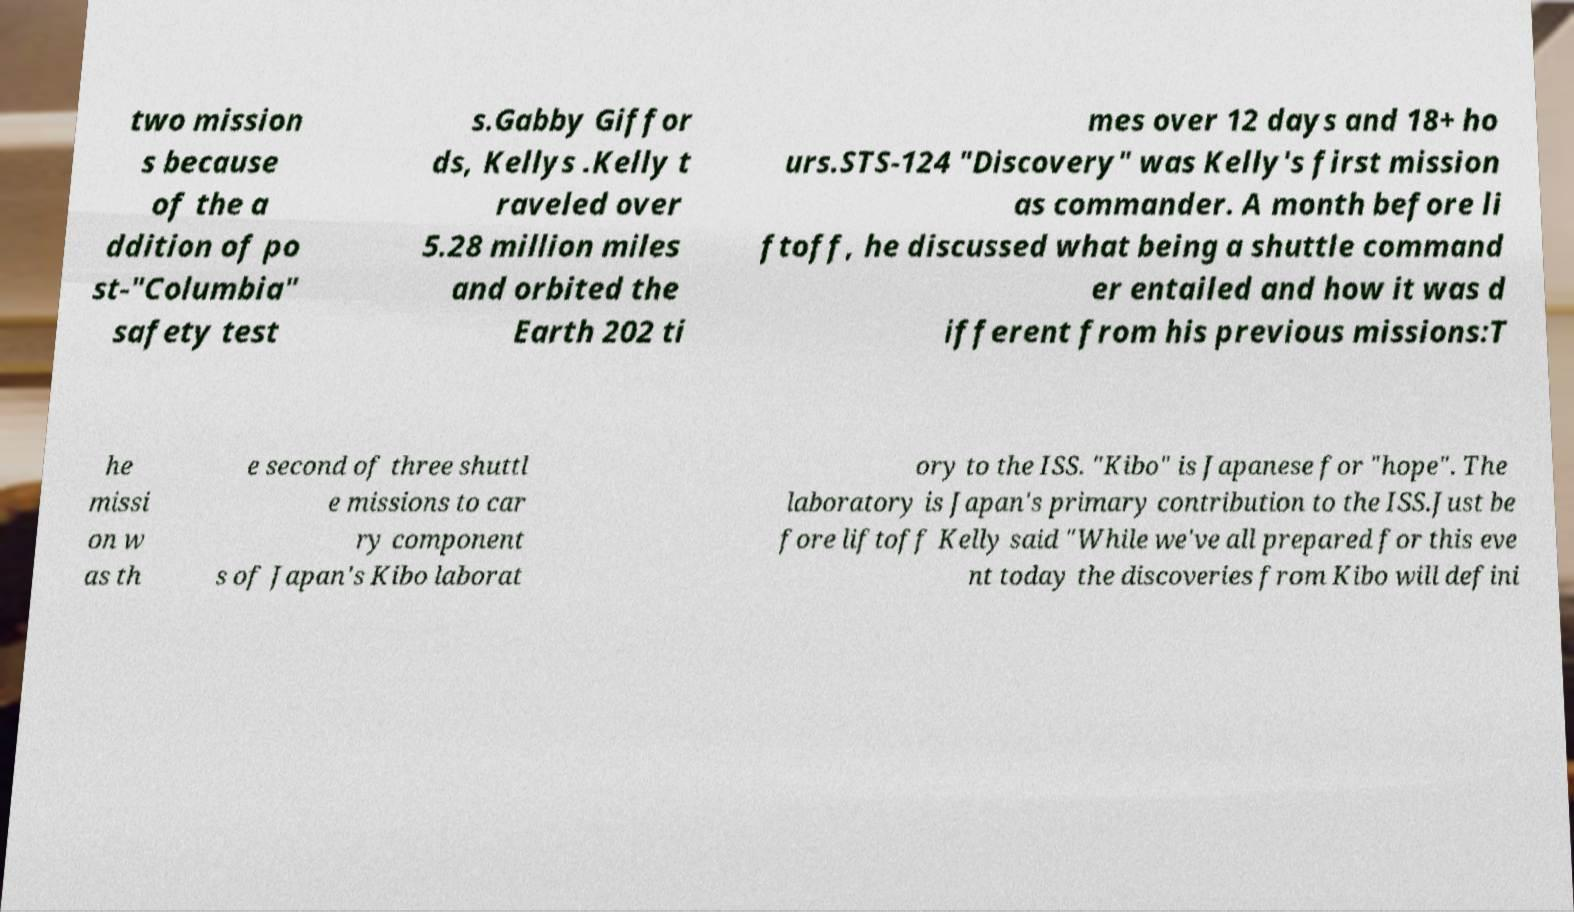Could you extract and type out the text from this image? two mission s because of the a ddition of po st-"Columbia" safety test s.Gabby Giffor ds, Kellys .Kelly t raveled over 5.28 million miles and orbited the Earth 202 ti mes over 12 days and 18+ ho urs.STS-124 "Discovery" was Kelly's first mission as commander. A month before li ftoff, he discussed what being a shuttle command er entailed and how it was d ifferent from his previous missions:T he missi on w as th e second of three shuttl e missions to car ry component s of Japan's Kibo laborat ory to the ISS. "Kibo" is Japanese for "hope". The laboratory is Japan's primary contribution to the ISS.Just be fore liftoff Kelly said "While we've all prepared for this eve nt today the discoveries from Kibo will defini 